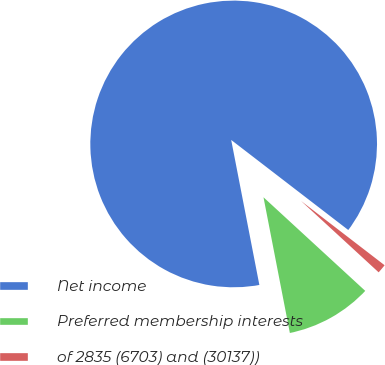<chart> <loc_0><loc_0><loc_500><loc_500><pie_chart><fcel>Net income<fcel>Preferred membership interests<fcel>of 2835 (6703) and (30137))<nl><fcel>88.49%<fcel>10.11%<fcel>1.4%<nl></chart> 